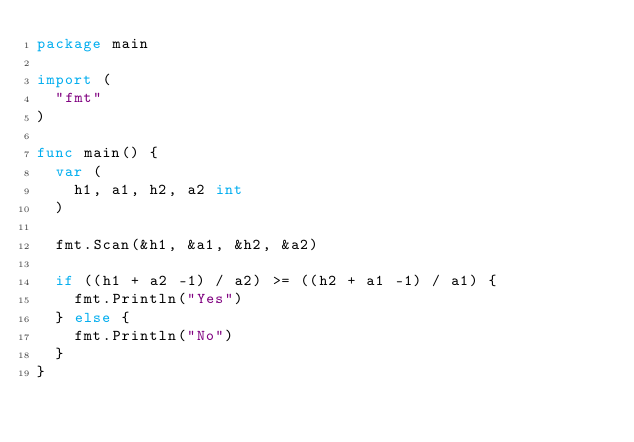<code> <loc_0><loc_0><loc_500><loc_500><_Go_>package main

import (
	"fmt"
)

func main() {
	var (
		h1, a1, h2, a2 int
	)

	fmt.Scan(&h1, &a1, &h2, &a2)

	if ((h1 + a2 -1) / a2) >= ((h2 + a1 -1) / a1) {
		fmt.Println("Yes")
	} else {
		fmt.Println("No")
	}
}</code> 